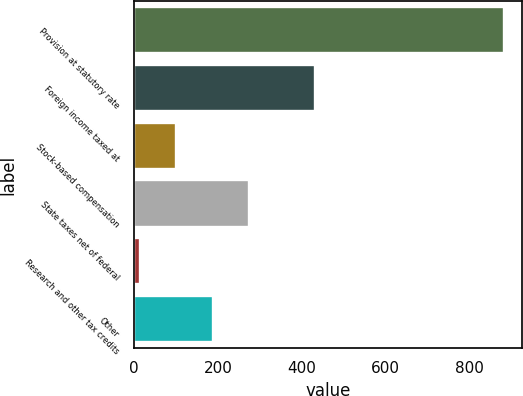Convert chart. <chart><loc_0><loc_0><loc_500><loc_500><bar_chart><fcel>Provision at statutory rate<fcel>Foreign income taxed at<fcel>Stock-based compensation<fcel>State taxes net of federal<fcel>Research and other tax credits<fcel>Other<nl><fcel>881<fcel>432<fcel>100.7<fcel>274.1<fcel>14<fcel>187.4<nl></chart> 